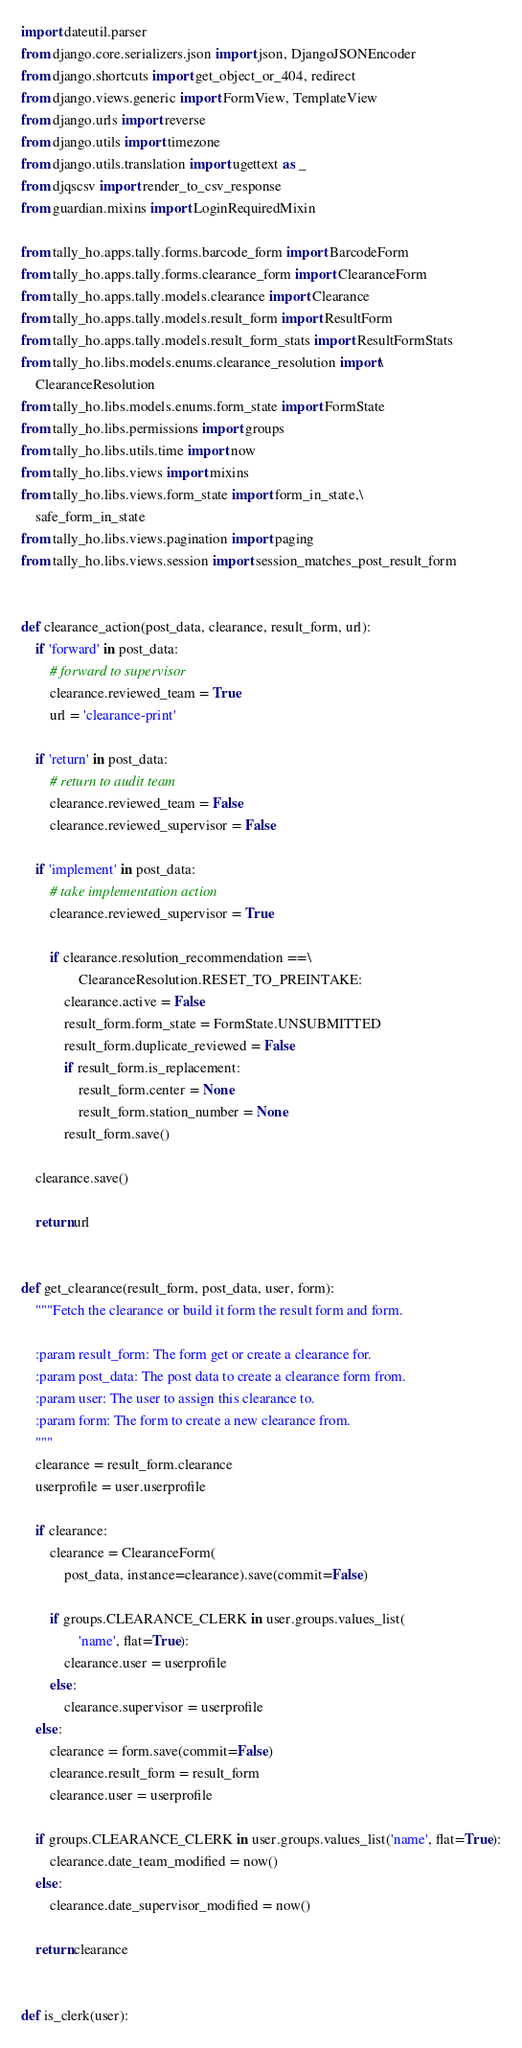Convert code to text. <code><loc_0><loc_0><loc_500><loc_500><_Python_>import dateutil.parser
from django.core.serializers.json import json, DjangoJSONEncoder
from django.shortcuts import get_object_or_404, redirect
from django.views.generic import FormView, TemplateView
from django.urls import reverse
from django.utils import timezone
from django.utils.translation import ugettext as _
from djqscsv import render_to_csv_response
from guardian.mixins import LoginRequiredMixin

from tally_ho.apps.tally.forms.barcode_form import BarcodeForm
from tally_ho.apps.tally.forms.clearance_form import ClearanceForm
from tally_ho.apps.tally.models.clearance import Clearance
from tally_ho.apps.tally.models.result_form import ResultForm
from tally_ho.apps.tally.models.result_form_stats import ResultFormStats
from tally_ho.libs.models.enums.clearance_resolution import\
    ClearanceResolution
from tally_ho.libs.models.enums.form_state import FormState
from tally_ho.libs.permissions import groups
from tally_ho.libs.utils.time import now
from tally_ho.libs.views import mixins
from tally_ho.libs.views.form_state import form_in_state,\
    safe_form_in_state
from tally_ho.libs.views.pagination import paging
from tally_ho.libs.views.session import session_matches_post_result_form


def clearance_action(post_data, clearance, result_form, url):
    if 'forward' in post_data:
        # forward to supervisor
        clearance.reviewed_team = True
        url = 'clearance-print'

    if 'return' in post_data:
        # return to audit team
        clearance.reviewed_team = False
        clearance.reviewed_supervisor = False

    if 'implement' in post_data:
        # take implementation action
        clearance.reviewed_supervisor = True

        if clearance.resolution_recommendation ==\
                ClearanceResolution.RESET_TO_PREINTAKE:
            clearance.active = False
            result_form.form_state = FormState.UNSUBMITTED
            result_form.duplicate_reviewed = False
            if result_form.is_replacement:
                result_form.center = None
                result_form.station_number = None
            result_form.save()

    clearance.save()

    return url


def get_clearance(result_form, post_data, user, form):
    """Fetch the clearance or build it form the result form and form.

    :param result_form: The form get or create a clearance for.
    :param post_data: The post data to create a clearance form from.
    :param user: The user to assign this clearance to.
    :param form: The form to create a new clearance from.
    """
    clearance = result_form.clearance
    userprofile = user.userprofile

    if clearance:
        clearance = ClearanceForm(
            post_data, instance=clearance).save(commit=False)

        if groups.CLEARANCE_CLERK in user.groups.values_list(
                'name', flat=True):
            clearance.user = userprofile
        else:
            clearance.supervisor = userprofile
    else:
        clearance = form.save(commit=False)
        clearance.result_form = result_form
        clearance.user = userprofile

    if groups.CLEARANCE_CLERK in user.groups.values_list('name', flat=True):
        clearance.date_team_modified = now()
    else:
        clearance.date_supervisor_modified = now()

    return clearance


def is_clerk(user):</code> 